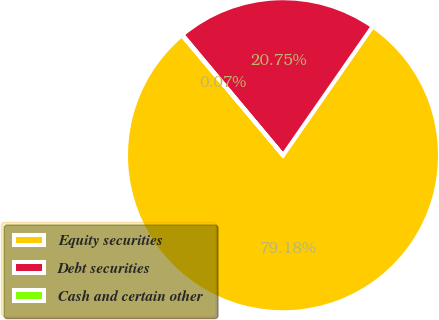Convert chart to OTSL. <chart><loc_0><loc_0><loc_500><loc_500><pie_chart><fcel>Equity securities<fcel>Debt securities<fcel>Cash and certain other<nl><fcel>79.18%<fcel>20.75%<fcel>0.07%<nl></chart> 